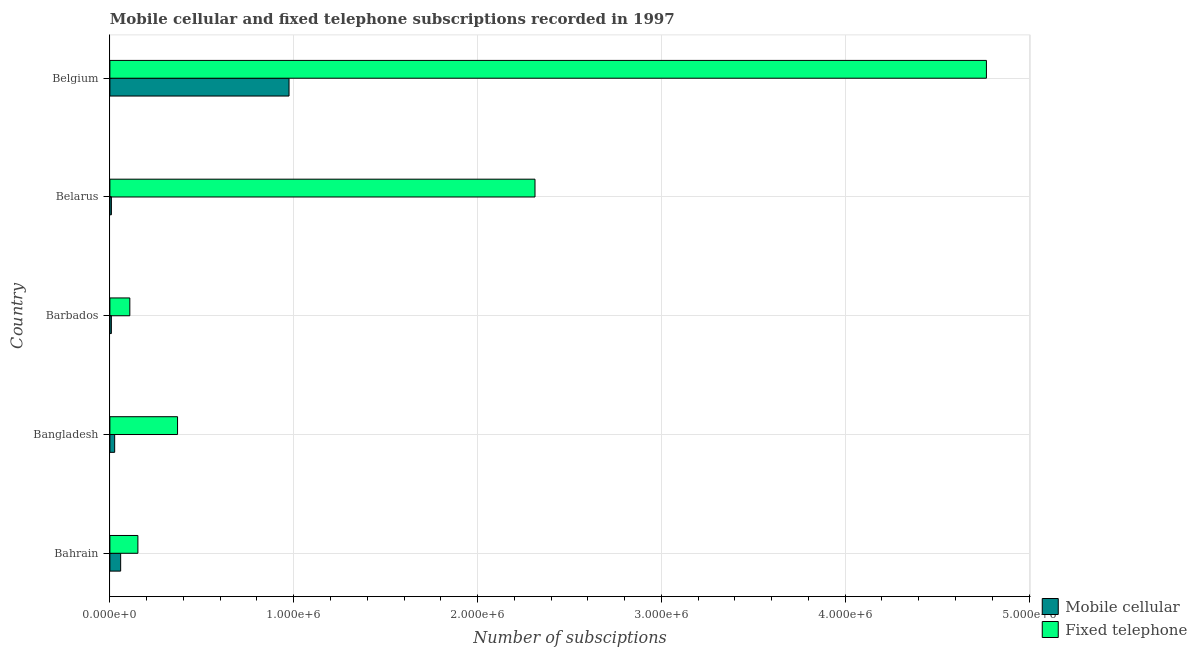How many different coloured bars are there?
Your response must be concise. 2. Are the number of bars per tick equal to the number of legend labels?
Keep it short and to the point. Yes. What is the label of the 5th group of bars from the top?
Ensure brevity in your answer.  Bahrain. What is the number of mobile cellular subscriptions in Bangladesh?
Offer a very short reply. 2.60e+04. Across all countries, what is the maximum number of fixed telephone subscriptions?
Your answer should be compact. 4.77e+06. Across all countries, what is the minimum number of mobile cellular subscriptions?
Provide a succinct answer. 8013. In which country was the number of mobile cellular subscriptions maximum?
Your response must be concise. Belgium. In which country was the number of fixed telephone subscriptions minimum?
Your answer should be very brief. Barbados. What is the total number of mobile cellular subscriptions in the graph?
Give a very brief answer. 1.08e+06. What is the difference between the number of mobile cellular subscriptions in Bahrain and that in Belarus?
Your answer should be compact. 5.04e+04. What is the difference between the number of fixed telephone subscriptions in Belgium and the number of mobile cellular subscriptions in Barbados?
Provide a short and direct response. 4.76e+06. What is the average number of mobile cellular subscriptions per country?
Ensure brevity in your answer.  2.15e+05. What is the difference between the number of mobile cellular subscriptions and number of fixed telephone subscriptions in Bangladesh?
Keep it short and to the point. -3.42e+05. In how many countries, is the number of mobile cellular subscriptions greater than 3200000 ?
Your answer should be very brief. 0. What is the difference between the highest and the second highest number of fixed telephone subscriptions?
Your answer should be very brief. 2.46e+06. What is the difference between the highest and the lowest number of fixed telephone subscriptions?
Offer a very short reply. 4.66e+06. What does the 1st bar from the top in Barbados represents?
Your response must be concise. Fixed telephone. What does the 1st bar from the bottom in Belarus represents?
Ensure brevity in your answer.  Mobile cellular. How many countries are there in the graph?
Ensure brevity in your answer.  5. Are the values on the major ticks of X-axis written in scientific E-notation?
Ensure brevity in your answer.  Yes. Does the graph contain any zero values?
Offer a terse response. No. Where does the legend appear in the graph?
Offer a very short reply. Bottom right. How are the legend labels stacked?
Keep it short and to the point. Vertical. What is the title of the graph?
Provide a succinct answer. Mobile cellular and fixed telephone subscriptions recorded in 1997. Does "Age 65(female)" appear as one of the legend labels in the graph?
Provide a short and direct response. No. What is the label or title of the X-axis?
Give a very brief answer. Number of subsciptions. What is the Number of subsciptions of Mobile cellular in Bahrain?
Offer a terse response. 5.85e+04. What is the Number of subsciptions in Fixed telephone in Bahrain?
Ensure brevity in your answer.  1.52e+05. What is the Number of subsciptions of Mobile cellular in Bangladesh?
Provide a short and direct response. 2.60e+04. What is the Number of subsciptions of Fixed telephone in Bangladesh?
Ensure brevity in your answer.  3.68e+05. What is the Number of subsciptions of Mobile cellular in Barbados?
Your response must be concise. 8013. What is the Number of subsciptions in Fixed telephone in Barbados?
Give a very brief answer. 1.08e+05. What is the Number of subsciptions in Mobile cellular in Belarus?
Keep it short and to the point. 8167. What is the Number of subsciptions of Fixed telephone in Belarus?
Ensure brevity in your answer.  2.31e+06. What is the Number of subsciptions of Mobile cellular in Belgium?
Keep it short and to the point. 9.74e+05. What is the Number of subsciptions of Fixed telephone in Belgium?
Offer a terse response. 4.77e+06. Across all countries, what is the maximum Number of subsciptions in Mobile cellular?
Your response must be concise. 9.74e+05. Across all countries, what is the maximum Number of subsciptions in Fixed telephone?
Make the answer very short. 4.77e+06. Across all countries, what is the minimum Number of subsciptions of Mobile cellular?
Make the answer very short. 8013. Across all countries, what is the minimum Number of subsciptions of Fixed telephone?
Provide a succinct answer. 1.08e+05. What is the total Number of subsciptions of Mobile cellular in the graph?
Provide a short and direct response. 1.08e+06. What is the total Number of subsciptions of Fixed telephone in the graph?
Give a very brief answer. 7.71e+06. What is the difference between the Number of subsciptions of Mobile cellular in Bahrain and that in Bangladesh?
Make the answer very short. 3.25e+04. What is the difference between the Number of subsciptions in Fixed telephone in Bahrain and that in Bangladesh?
Keep it short and to the point. -2.16e+05. What is the difference between the Number of subsciptions in Mobile cellular in Bahrain and that in Barbados?
Provide a succinct answer. 5.05e+04. What is the difference between the Number of subsciptions in Fixed telephone in Bahrain and that in Barbados?
Ensure brevity in your answer.  4.38e+04. What is the difference between the Number of subsciptions in Mobile cellular in Bahrain and that in Belarus?
Keep it short and to the point. 5.04e+04. What is the difference between the Number of subsciptions in Fixed telephone in Bahrain and that in Belarus?
Provide a succinct answer. -2.16e+06. What is the difference between the Number of subsciptions of Mobile cellular in Bahrain and that in Belgium?
Make the answer very short. -9.16e+05. What is the difference between the Number of subsciptions in Fixed telephone in Bahrain and that in Belgium?
Offer a very short reply. -4.62e+06. What is the difference between the Number of subsciptions in Mobile cellular in Bangladesh and that in Barbados?
Your answer should be compact. 1.80e+04. What is the difference between the Number of subsciptions of Fixed telephone in Bangladesh and that in Barbados?
Provide a succinct answer. 2.60e+05. What is the difference between the Number of subsciptions of Mobile cellular in Bangladesh and that in Belarus?
Provide a succinct answer. 1.78e+04. What is the difference between the Number of subsciptions in Fixed telephone in Bangladesh and that in Belarus?
Offer a terse response. -1.94e+06. What is the difference between the Number of subsciptions in Mobile cellular in Bangladesh and that in Belgium?
Offer a terse response. -9.48e+05. What is the difference between the Number of subsciptions in Fixed telephone in Bangladesh and that in Belgium?
Your answer should be compact. -4.40e+06. What is the difference between the Number of subsciptions of Mobile cellular in Barbados and that in Belarus?
Ensure brevity in your answer.  -154. What is the difference between the Number of subsciptions in Fixed telephone in Barbados and that in Belarus?
Keep it short and to the point. -2.20e+06. What is the difference between the Number of subsciptions of Mobile cellular in Barbados and that in Belgium?
Your answer should be very brief. -9.66e+05. What is the difference between the Number of subsciptions of Fixed telephone in Barbados and that in Belgium?
Make the answer very short. -4.66e+06. What is the difference between the Number of subsciptions in Mobile cellular in Belarus and that in Belgium?
Keep it short and to the point. -9.66e+05. What is the difference between the Number of subsciptions of Fixed telephone in Belarus and that in Belgium?
Ensure brevity in your answer.  -2.46e+06. What is the difference between the Number of subsciptions in Mobile cellular in Bahrain and the Number of subsciptions in Fixed telephone in Bangladesh?
Give a very brief answer. -3.09e+05. What is the difference between the Number of subsciptions in Mobile cellular in Bahrain and the Number of subsciptions in Fixed telephone in Barbados?
Offer a terse response. -4.99e+04. What is the difference between the Number of subsciptions of Mobile cellular in Bahrain and the Number of subsciptions of Fixed telephone in Belarus?
Offer a terse response. -2.25e+06. What is the difference between the Number of subsciptions of Mobile cellular in Bahrain and the Number of subsciptions of Fixed telephone in Belgium?
Offer a very short reply. -4.71e+06. What is the difference between the Number of subsciptions of Mobile cellular in Bangladesh and the Number of subsciptions of Fixed telephone in Barbados?
Give a very brief answer. -8.25e+04. What is the difference between the Number of subsciptions of Mobile cellular in Bangladesh and the Number of subsciptions of Fixed telephone in Belarus?
Your answer should be very brief. -2.29e+06. What is the difference between the Number of subsciptions of Mobile cellular in Bangladesh and the Number of subsciptions of Fixed telephone in Belgium?
Offer a very short reply. -4.74e+06. What is the difference between the Number of subsciptions in Mobile cellular in Barbados and the Number of subsciptions in Fixed telephone in Belarus?
Make the answer very short. -2.30e+06. What is the difference between the Number of subsciptions of Mobile cellular in Barbados and the Number of subsciptions of Fixed telephone in Belgium?
Your answer should be very brief. -4.76e+06. What is the difference between the Number of subsciptions in Mobile cellular in Belarus and the Number of subsciptions in Fixed telephone in Belgium?
Offer a very short reply. -4.76e+06. What is the average Number of subsciptions in Mobile cellular per country?
Keep it short and to the point. 2.15e+05. What is the average Number of subsciptions of Fixed telephone per country?
Offer a very short reply. 1.54e+06. What is the difference between the Number of subsciptions in Mobile cellular and Number of subsciptions in Fixed telephone in Bahrain?
Ensure brevity in your answer.  -9.38e+04. What is the difference between the Number of subsciptions of Mobile cellular and Number of subsciptions of Fixed telephone in Bangladesh?
Ensure brevity in your answer.  -3.42e+05. What is the difference between the Number of subsciptions in Mobile cellular and Number of subsciptions in Fixed telephone in Barbados?
Ensure brevity in your answer.  -1.00e+05. What is the difference between the Number of subsciptions in Mobile cellular and Number of subsciptions in Fixed telephone in Belarus?
Your response must be concise. -2.30e+06. What is the difference between the Number of subsciptions in Mobile cellular and Number of subsciptions in Fixed telephone in Belgium?
Your answer should be very brief. -3.79e+06. What is the ratio of the Number of subsciptions in Mobile cellular in Bahrain to that in Bangladesh?
Keep it short and to the point. 2.25. What is the ratio of the Number of subsciptions in Fixed telephone in Bahrain to that in Bangladesh?
Ensure brevity in your answer.  0.41. What is the ratio of the Number of subsciptions of Mobile cellular in Bahrain to that in Barbados?
Offer a terse response. 7.31. What is the ratio of the Number of subsciptions of Fixed telephone in Bahrain to that in Barbados?
Offer a very short reply. 1.4. What is the ratio of the Number of subsciptions in Mobile cellular in Bahrain to that in Belarus?
Your response must be concise. 7.17. What is the ratio of the Number of subsciptions in Fixed telephone in Bahrain to that in Belarus?
Provide a succinct answer. 0.07. What is the ratio of the Number of subsciptions of Mobile cellular in Bahrain to that in Belgium?
Provide a short and direct response. 0.06. What is the ratio of the Number of subsciptions of Fixed telephone in Bahrain to that in Belgium?
Your response must be concise. 0.03. What is the ratio of the Number of subsciptions in Mobile cellular in Bangladesh to that in Barbados?
Offer a terse response. 3.24. What is the ratio of the Number of subsciptions of Fixed telephone in Bangladesh to that in Barbados?
Your response must be concise. 3.39. What is the ratio of the Number of subsciptions in Mobile cellular in Bangladesh to that in Belarus?
Make the answer very short. 3.18. What is the ratio of the Number of subsciptions of Fixed telephone in Bangladesh to that in Belarus?
Provide a succinct answer. 0.16. What is the ratio of the Number of subsciptions of Mobile cellular in Bangladesh to that in Belgium?
Your answer should be very brief. 0.03. What is the ratio of the Number of subsciptions of Fixed telephone in Bangladesh to that in Belgium?
Keep it short and to the point. 0.08. What is the ratio of the Number of subsciptions in Mobile cellular in Barbados to that in Belarus?
Offer a very short reply. 0.98. What is the ratio of the Number of subsciptions in Fixed telephone in Barbados to that in Belarus?
Provide a succinct answer. 0.05. What is the ratio of the Number of subsciptions of Mobile cellular in Barbados to that in Belgium?
Offer a terse response. 0.01. What is the ratio of the Number of subsciptions in Fixed telephone in Barbados to that in Belgium?
Ensure brevity in your answer.  0.02. What is the ratio of the Number of subsciptions in Mobile cellular in Belarus to that in Belgium?
Your answer should be compact. 0.01. What is the ratio of the Number of subsciptions in Fixed telephone in Belarus to that in Belgium?
Provide a succinct answer. 0.48. What is the difference between the highest and the second highest Number of subsciptions of Mobile cellular?
Give a very brief answer. 9.16e+05. What is the difference between the highest and the second highest Number of subsciptions in Fixed telephone?
Your answer should be compact. 2.46e+06. What is the difference between the highest and the lowest Number of subsciptions of Mobile cellular?
Your response must be concise. 9.66e+05. What is the difference between the highest and the lowest Number of subsciptions of Fixed telephone?
Provide a succinct answer. 4.66e+06. 